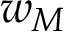<formula> <loc_0><loc_0><loc_500><loc_500>w _ { M }</formula> 